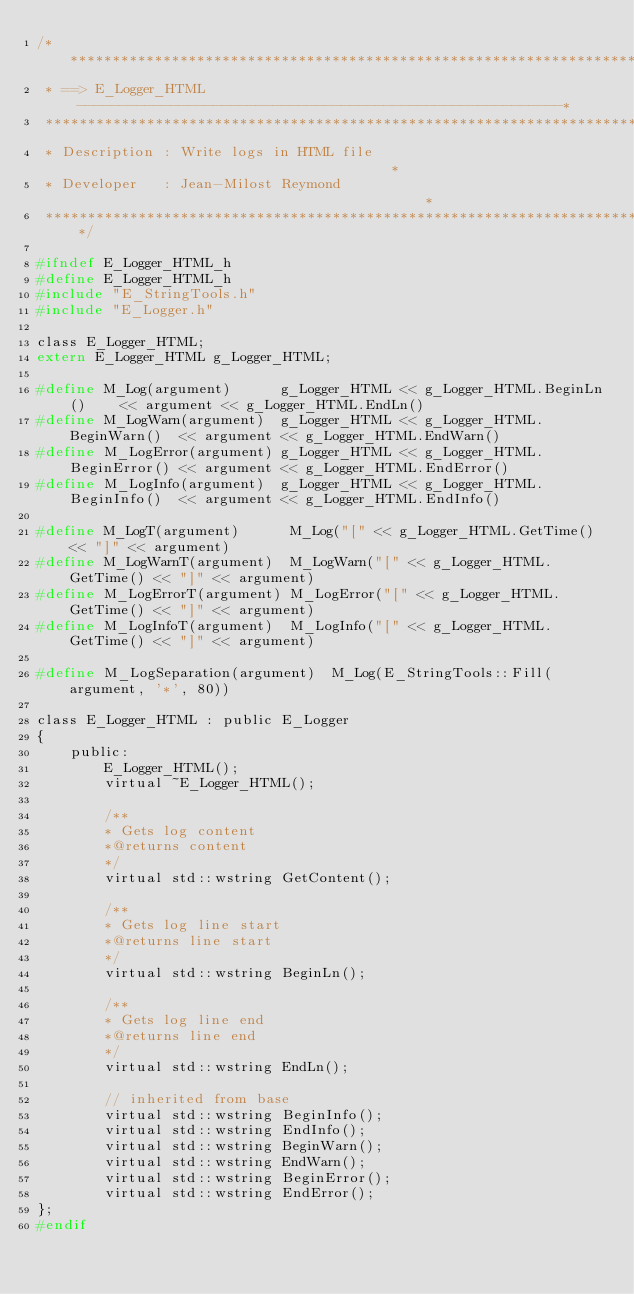Convert code to text. <code><loc_0><loc_0><loc_500><loc_500><_C_>/******************************************************************************
 * ==> E_Logger_HTML ---------------------------------------------------------*
 ******************************************************************************
 * Description : Write logs in HTML file                                      *
 * Developer   : Jean-Milost Reymond                                          *
 ******************************************************************************/

#ifndef E_Logger_HTML_h
#define E_Logger_HTML_h
#include "E_StringTools.h"
#include "E_Logger.h"

class E_Logger_HTML;
extern E_Logger_HTML g_Logger_HTML;

#define M_Log(argument)      g_Logger_HTML << g_Logger_HTML.BeginLn()    << argument << g_Logger_HTML.EndLn()
#define M_LogWarn(argument)  g_Logger_HTML << g_Logger_HTML.BeginWarn()  << argument << g_Logger_HTML.EndWarn()
#define M_LogError(argument) g_Logger_HTML << g_Logger_HTML.BeginError() << argument << g_Logger_HTML.EndError()
#define M_LogInfo(argument)  g_Logger_HTML << g_Logger_HTML.BeginInfo()  << argument << g_Logger_HTML.EndInfo()

#define M_LogT(argument)      M_Log("[" << g_Logger_HTML.GetTime() << "]" << argument)
#define M_LogWarnT(argument)  M_LogWarn("[" << g_Logger_HTML.GetTime() << "]" << argument)
#define M_LogErrorT(argument) M_LogError("[" << g_Logger_HTML.GetTime() << "]" << argument)
#define M_LogInfoT(argument)  M_LogInfo("[" << g_Logger_HTML.GetTime() << "]" << argument)

#define M_LogSeparation(argument)  M_Log(E_StringTools::Fill(argument, '*', 80))

class E_Logger_HTML : public E_Logger
{
    public:
        E_Logger_HTML();
        virtual ~E_Logger_HTML();

        /**
        * Gets log content
        *@returns content
        */
        virtual std::wstring GetContent();

        /**
        * Gets log line start
        *@returns line start
        */
        virtual std::wstring BeginLn();

        /**
        * Gets log line end
        *@returns line end
        */
        virtual std::wstring EndLn();

        // inherited from base
        virtual std::wstring BeginInfo();
        virtual std::wstring EndInfo();
        virtual std::wstring BeginWarn();
        virtual std::wstring EndWarn();
        virtual std::wstring BeginError();
        virtual std::wstring EndError();
};
#endif
</code> 